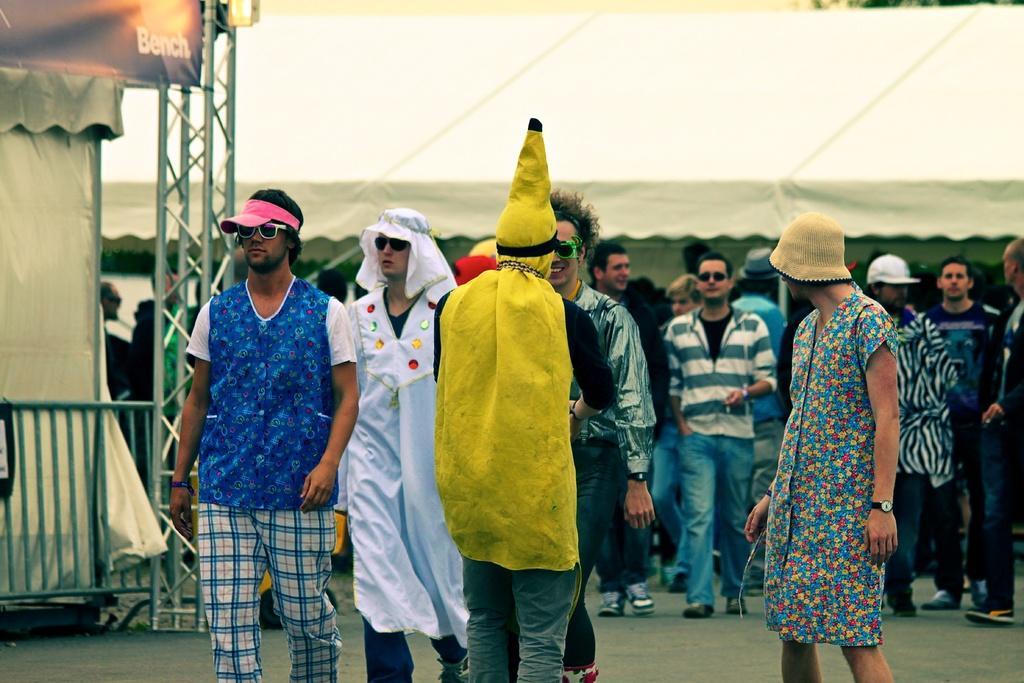Could you give a brief overview of what you see in this image? In the image we can see there are people standing on the road and they are wearing costumes. There are few people wearing sunglasses and there are iron poles. Behind there are tents. 